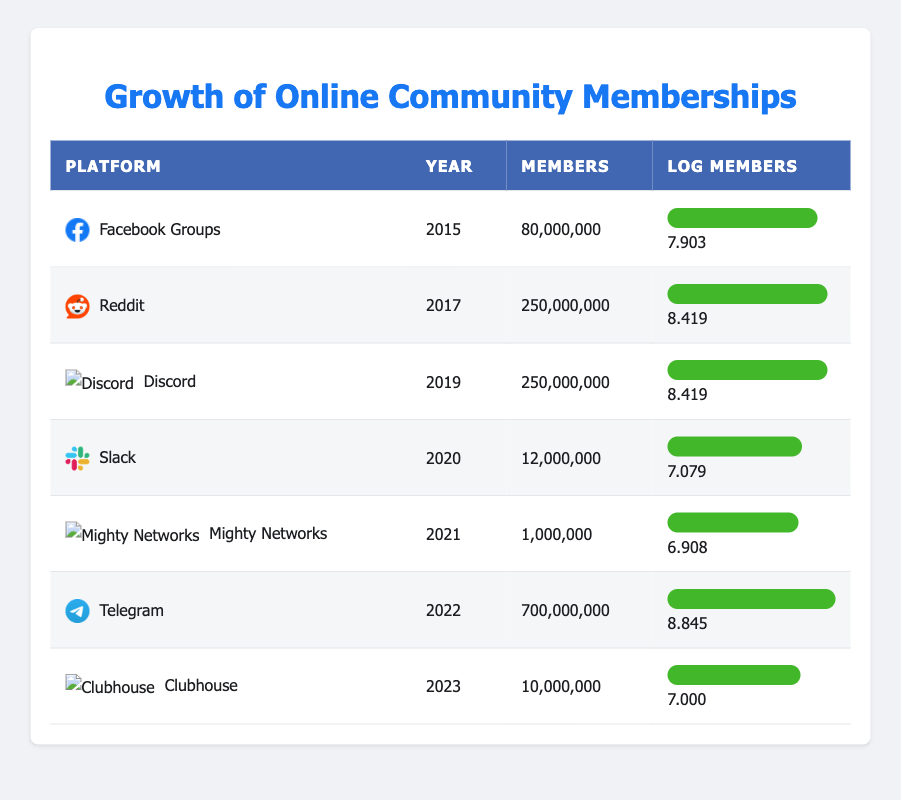What is the total number of members across all platforms listed? To find the total number of members, we add the number of members from each platform: 80,000,000 (Facebook) + 250,000,000 (Reddit) + 250,000,000 (Discord) + 12,000,000 (Slack) + 1,000,000 (Mighty Networks) + 700,000,000 (Telegram) + 10,000,000 (Clubhouse) = 1,303,000,000
Answer: 1,303,000,000 In which year did Telegram reach the highest number of members? Looking at the members column, Telegram has 700,000,000 members in 2022, which is greater than any other platform's member count listed in the table. Therefore, 2022 is the year when Telegram reached the highest membership.
Answer: 2022 Which platform had the largest membership in 2019? In 2019, the platforms listed are Discord with 250,000,000 members. No other platforms are listed for that year, so Discord had the largest membership for that year.
Answer: Discord Is the number of members for Slack greater than Mighty Networks? From the table, Slack has 12,000,000 members while Mighty Networks has 1,000,000 members. Therefore, Slack does have more members than Mighty Networks.
Answer: Yes What is the average number of members for platforms from 2015 to 2023? To find the average, we first sum the members: 80,000,000 + 250,000,000 + 250,000,000 + 12,000,000 + 1,000,000 + 700,000,000 + 10,000,000 = 1,303,000,000. There are seven platforms, so we divide the total by 7, which gives 1,303,000,000 / 7 ≈ 186,142,857
Answer: 186,142,857 Does any platform have a logarithmic value of members greater than 8.5? By examining the log members column, only Telegram has a value of 8.845, which is indeed greater than 8.5. Thus, there is at least one platform meeting this criterion.
Answer: Yes 